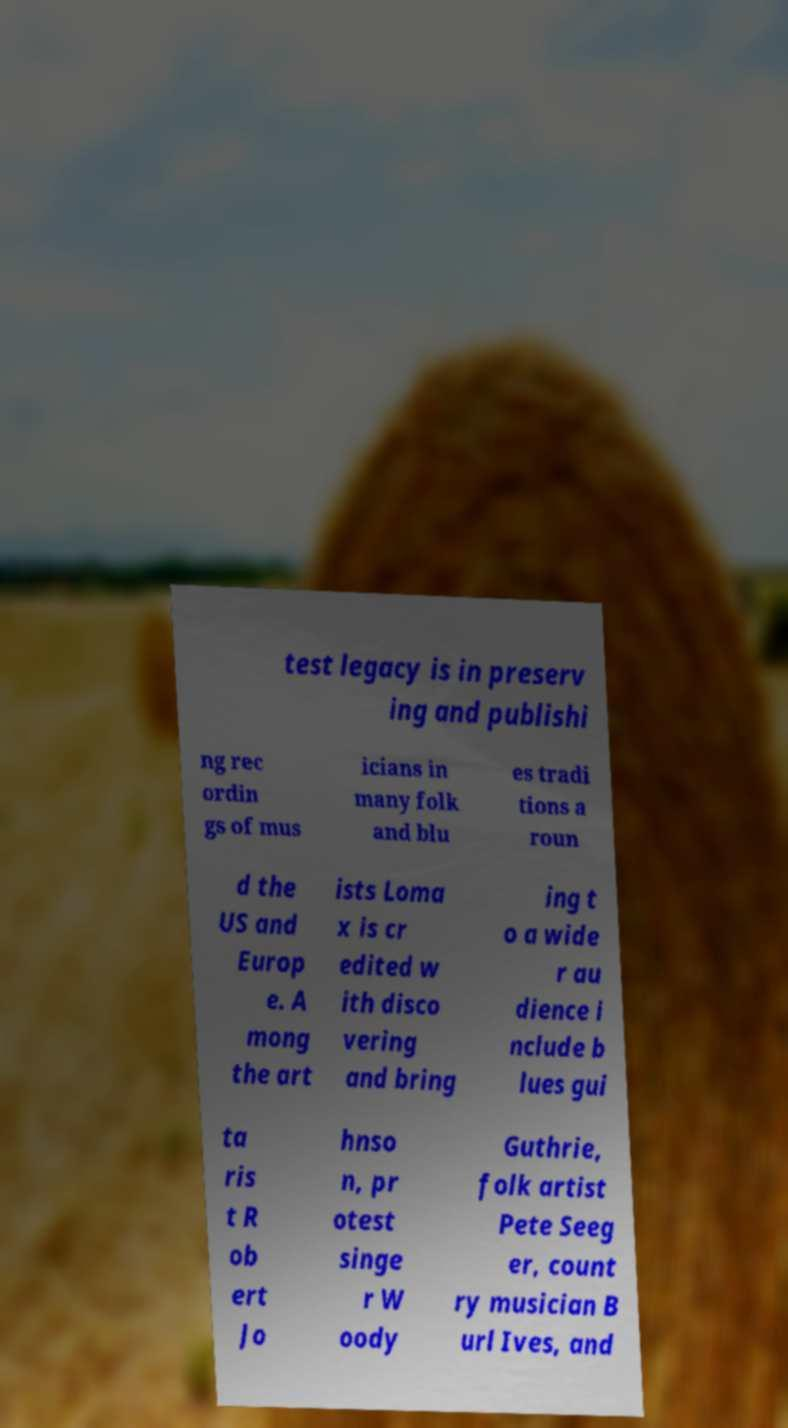I need the written content from this picture converted into text. Can you do that? test legacy is in preserv ing and publishi ng rec ordin gs of mus icians in many folk and blu es tradi tions a roun d the US and Europ e. A mong the art ists Loma x is cr edited w ith disco vering and bring ing t o a wide r au dience i nclude b lues gui ta ris t R ob ert Jo hnso n, pr otest singe r W oody Guthrie, folk artist Pete Seeg er, count ry musician B url Ives, and 